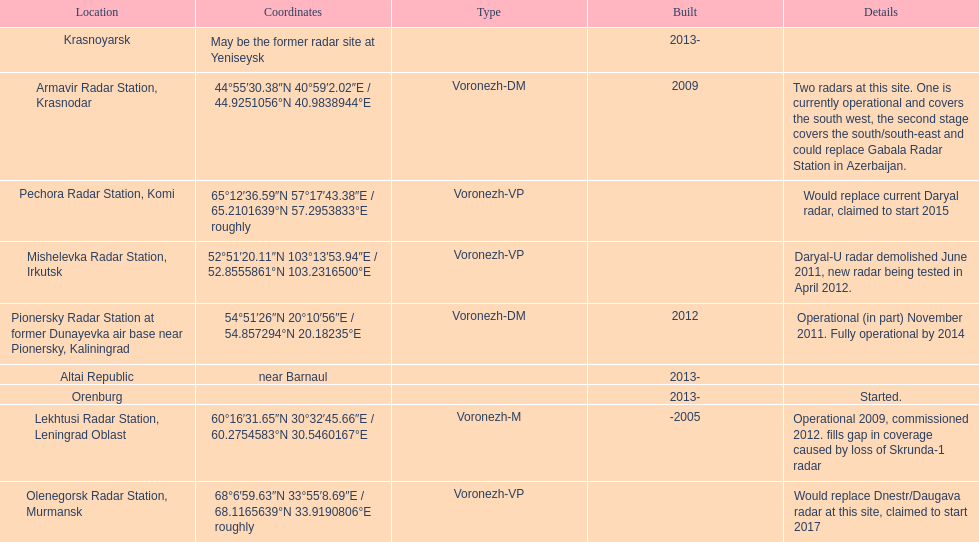Which site has the most radars? Armavir Radar Station, Krasnodar. 